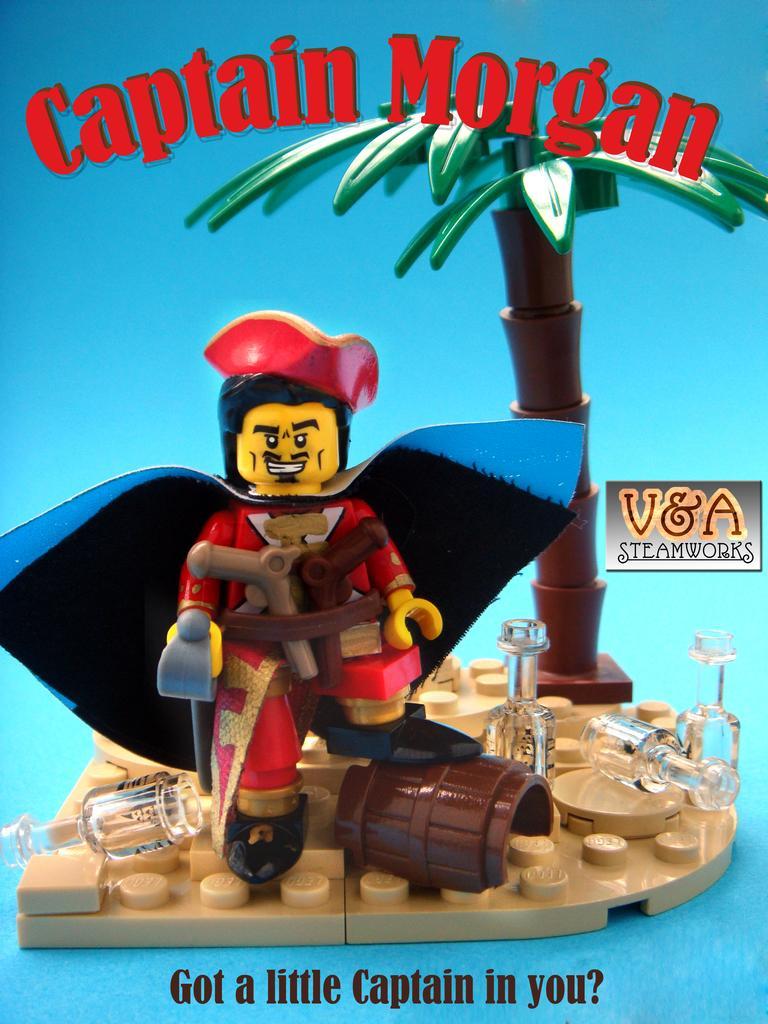Describe this image in one or two sentences. In this image we can see a poster with toy, objects and blue background. And we can see the text written on the poster. 